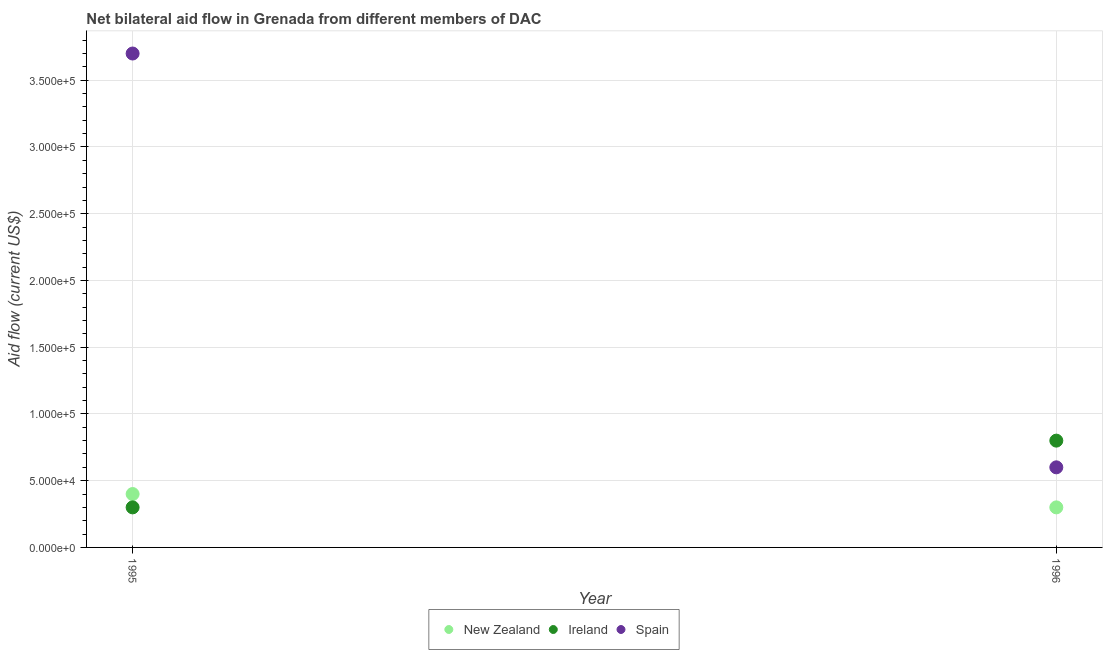What is the amount of aid provided by ireland in 1996?
Offer a very short reply. 8.00e+04. Across all years, what is the maximum amount of aid provided by ireland?
Offer a very short reply. 8.00e+04. Across all years, what is the minimum amount of aid provided by new zealand?
Your response must be concise. 3.00e+04. In which year was the amount of aid provided by ireland maximum?
Offer a very short reply. 1996. What is the total amount of aid provided by spain in the graph?
Keep it short and to the point. 4.30e+05. What is the difference between the amount of aid provided by spain in 1995 and that in 1996?
Provide a short and direct response. 3.10e+05. What is the difference between the amount of aid provided by new zealand in 1996 and the amount of aid provided by spain in 1995?
Offer a terse response. -3.40e+05. What is the average amount of aid provided by new zealand per year?
Your answer should be compact. 3.50e+04. In the year 1996, what is the difference between the amount of aid provided by new zealand and amount of aid provided by ireland?
Ensure brevity in your answer.  -5.00e+04. What is the ratio of the amount of aid provided by new zealand in 1995 to that in 1996?
Provide a succinct answer. 1.33. Is the amount of aid provided by spain in 1995 less than that in 1996?
Your answer should be compact. No. In how many years, is the amount of aid provided by ireland greater than the average amount of aid provided by ireland taken over all years?
Offer a very short reply. 1. Is the amount of aid provided by spain strictly greater than the amount of aid provided by new zealand over the years?
Your answer should be compact. Yes. Is the amount of aid provided by spain strictly less than the amount of aid provided by ireland over the years?
Provide a short and direct response. No. How many years are there in the graph?
Your answer should be very brief. 2. What is the difference between two consecutive major ticks on the Y-axis?
Keep it short and to the point. 5.00e+04. Does the graph contain any zero values?
Make the answer very short. No. Does the graph contain grids?
Make the answer very short. Yes. How many legend labels are there?
Your answer should be very brief. 3. How are the legend labels stacked?
Keep it short and to the point. Horizontal. What is the title of the graph?
Provide a short and direct response. Net bilateral aid flow in Grenada from different members of DAC. What is the label or title of the Y-axis?
Provide a succinct answer. Aid flow (current US$). What is the Aid flow (current US$) in New Zealand in 1995?
Make the answer very short. 4.00e+04. What is the Aid flow (current US$) of Ireland in 1995?
Keep it short and to the point. 3.00e+04. What is the Aid flow (current US$) of Spain in 1995?
Offer a terse response. 3.70e+05. What is the Aid flow (current US$) of New Zealand in 1996?
Provide a succinct answer. 3.00e+04. What is the Aid flow (current US$) of Ireland in 1996?
Your response must be concise. 8.00e+04. What is the Aid flow (current US$) of Spain in 1996?
Offer a very short reply. 6.00e+04. Across all years, what is the maximum Aid flow (current US$) of New Zealand?
Keep it short and to the point. 4.00e+04. Across all years, what is the maximum Aid flow (current US$) of Ireland?
Ensure brevity in your answer.  8.00e+04. Across all years, what is the minimum Aid flow (current US$) in New Zealand?
Ensure brevity in your answer.  3.00e+04. Across all years, what is the minimum Aid flow (current US$) of Ireland?
Ensure brevity in your answer.  3.00e+04. What is the total Aid flow (current US$) of Ireland in the graph?
Your answer should be very brief. 1.10e+05. What is the difference between the Aid flow (current US$) in New Zealand in 1995 and that in 1996?
Offer a very short reply. 10000. What is the difference between the Aid flow (current US$) of Spain in 1995 and that in 1996?
Give a very brief answer. 3.10e+05. What is the difference between the Aid flow (current US$) of New Zealand in 1995 and the Aid flow (current US$) of Ireland in 1996?
Give a very brief answer. -4.00e+04. What is the average Aid flow (current US$) of New Zealand per year?
Your response must be concise. 3.50e+04. What is the average Aid flow (current US$) of Ireland per year?
Offer a terse response. 5.50e+04. What is the average Aid flow (current US$) of Spain per year?
Keep it short and to the point. 2.15e+05. In the year 1995, what is the difference between the Aid flow (current US$) of New Zealand and Aid flow (current US$) of Spain?
Offer a very short reply. -3.30e+05. In the year 1996, what is the difference between the Aid flow (current US$) of New Zealand and Aid flow (current US$) of Ireland?
Your answer should be very brief. -5.00e+04. In the year 1996, what is the difference between the Aid flow (current US$) in New Zealand and Aid flow (current US$) in Spain?
Your answer should be compact. -3.00e+04. What is the ratio of the Aid flow (current US$) of New Zealand in 1995 to that in 1996?
Give a very brief answer. 1.33. What is the ratio of the Aid flow (current US$) in Spain in 1995 to that in 1996?
Make the answer very short. 6.17. What is the difference between the highest and the second highest Aid flow (current US$) of New Zealand?
Offer a terse response. 10000. What is the difference between the highest and the second highest Aid flow (current US$) in Ireland?
Provide a succinct answer. 5.00e+04. What is the difference between the highest and the second highest Aid flow (current US$) of Spain?
Make the answer very short. 3.10e+05. What is the difference between the highest and the lowest Aid flow (current US$) in New Zealand?
Your response must be concise. 10000. What is the difference between the highest and the lowest Aid flow (current US$) of Ireland?
Give a very brief answer. 5.00e+04. 